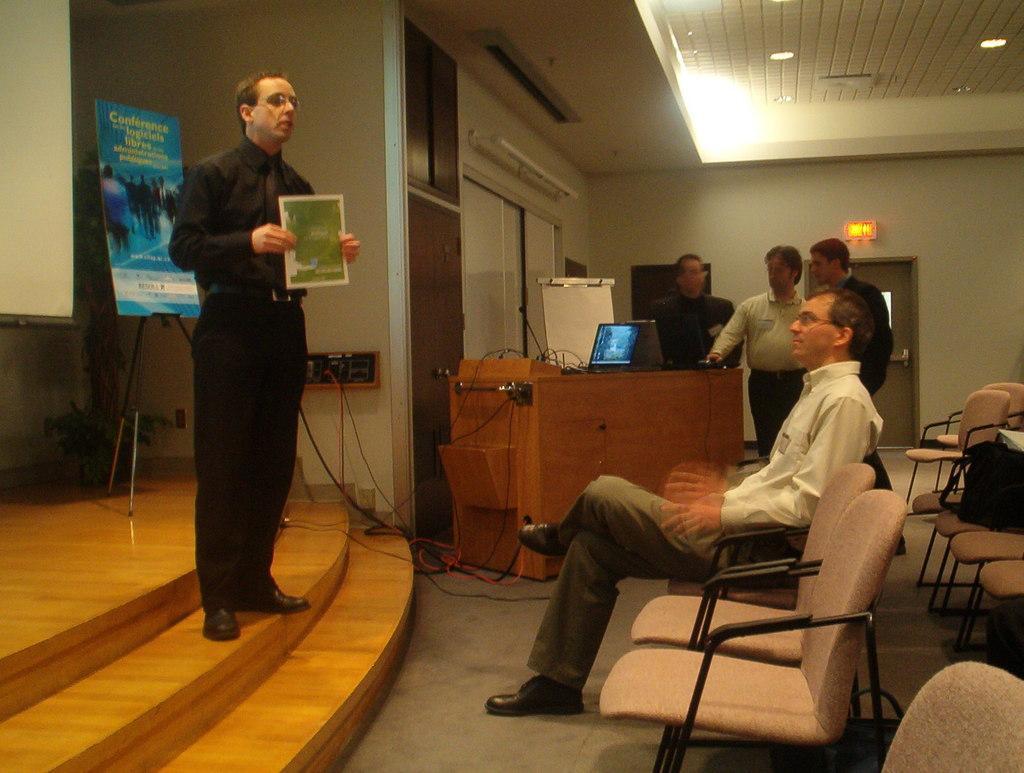Could you give a brief overview of what you see in this image? This picture is of inside the room. On the right we can see there are many chairs and there is a person wearing white color shirt and sitting on the chair. On the left there is a man wearing black color shirt ,holding a paper and standing on the steps, behind him we can see a poster attached to the stand and a projector screen. In the background we can see group of people standing and there is a table on the top of which a microphone and laptops are placed and we can see the door and the wall. 